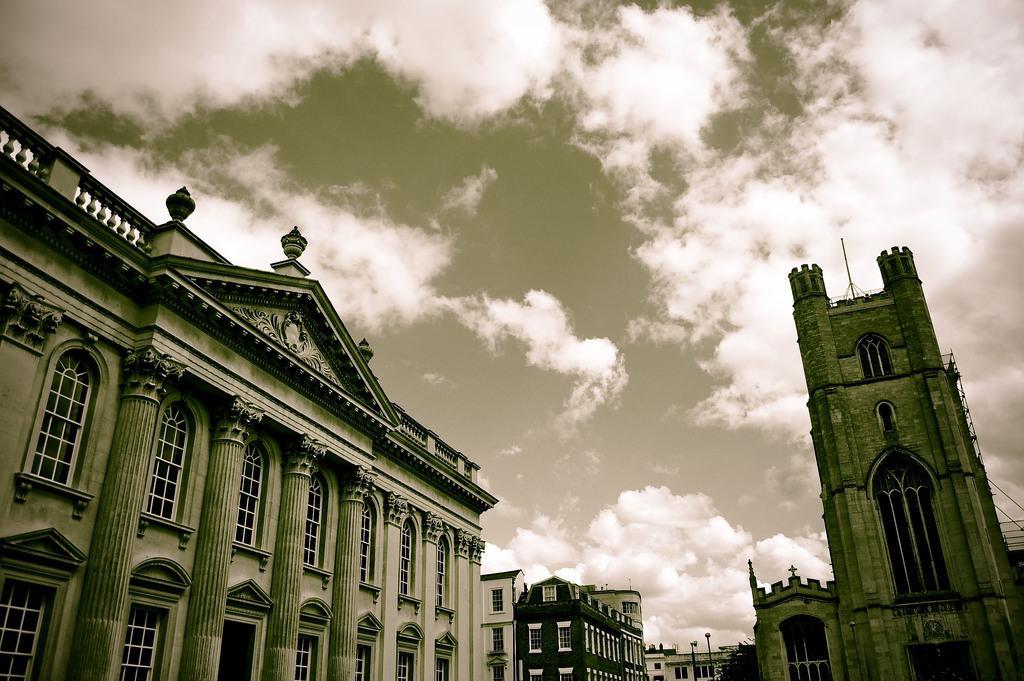Could you give a brief overview of what you see in this image? Here we can see buildings and windows. In the background there is sky with clouds. 